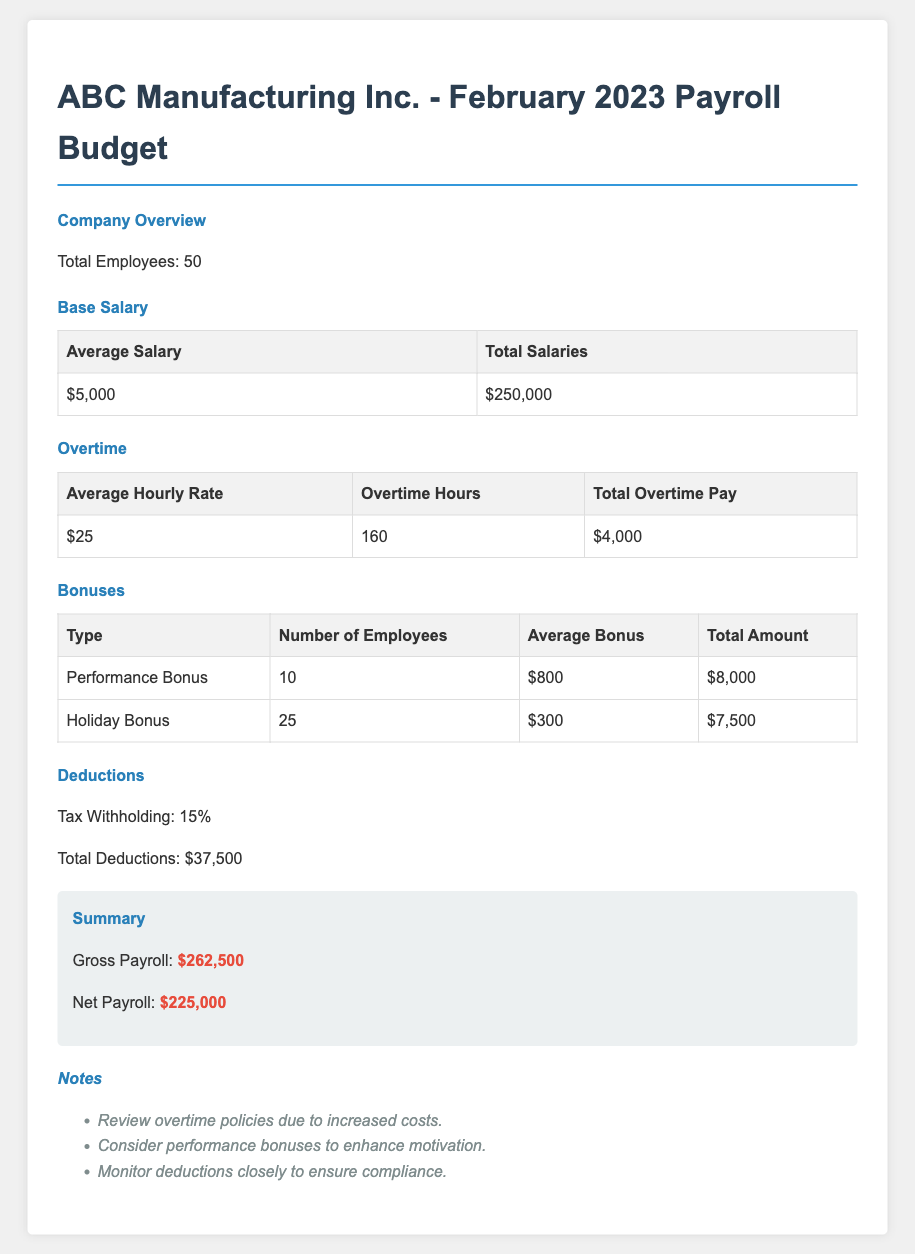What is the total number of employees? The document states that there are 50 employees in total.
Answer: 50 What is the average salary per employee? The average salary listed in the salary section is $5,000.
Answer: $5,000 How much did the company spend on total overtime pay? The total overtime pay specified in the document is $4,000.
Answer: $4,000 What is the total number of employees receiving performance bonuses? The document indicates that 10 employees received performance bonuses.
Answer: 10 What is the total amount of holiday bonuses? The document lists the total amount of holiday bonuses as $7,500.
Answer: $7,500 What percentage is deducted for tax withholding? The document mentions that the tax withholding is 15%.
Answer: 15% What is the gross payroll reported in the budget? The gross payroll stated in the summary is $262,500.
Answer: $262,500 What are the total deductions from the payroll? The total deductions listed in the document are $37,500.
Answer: $37,500 How many hours of overtime were recorded? The document notes that there were 160 overtime hours.
Answer: 160 